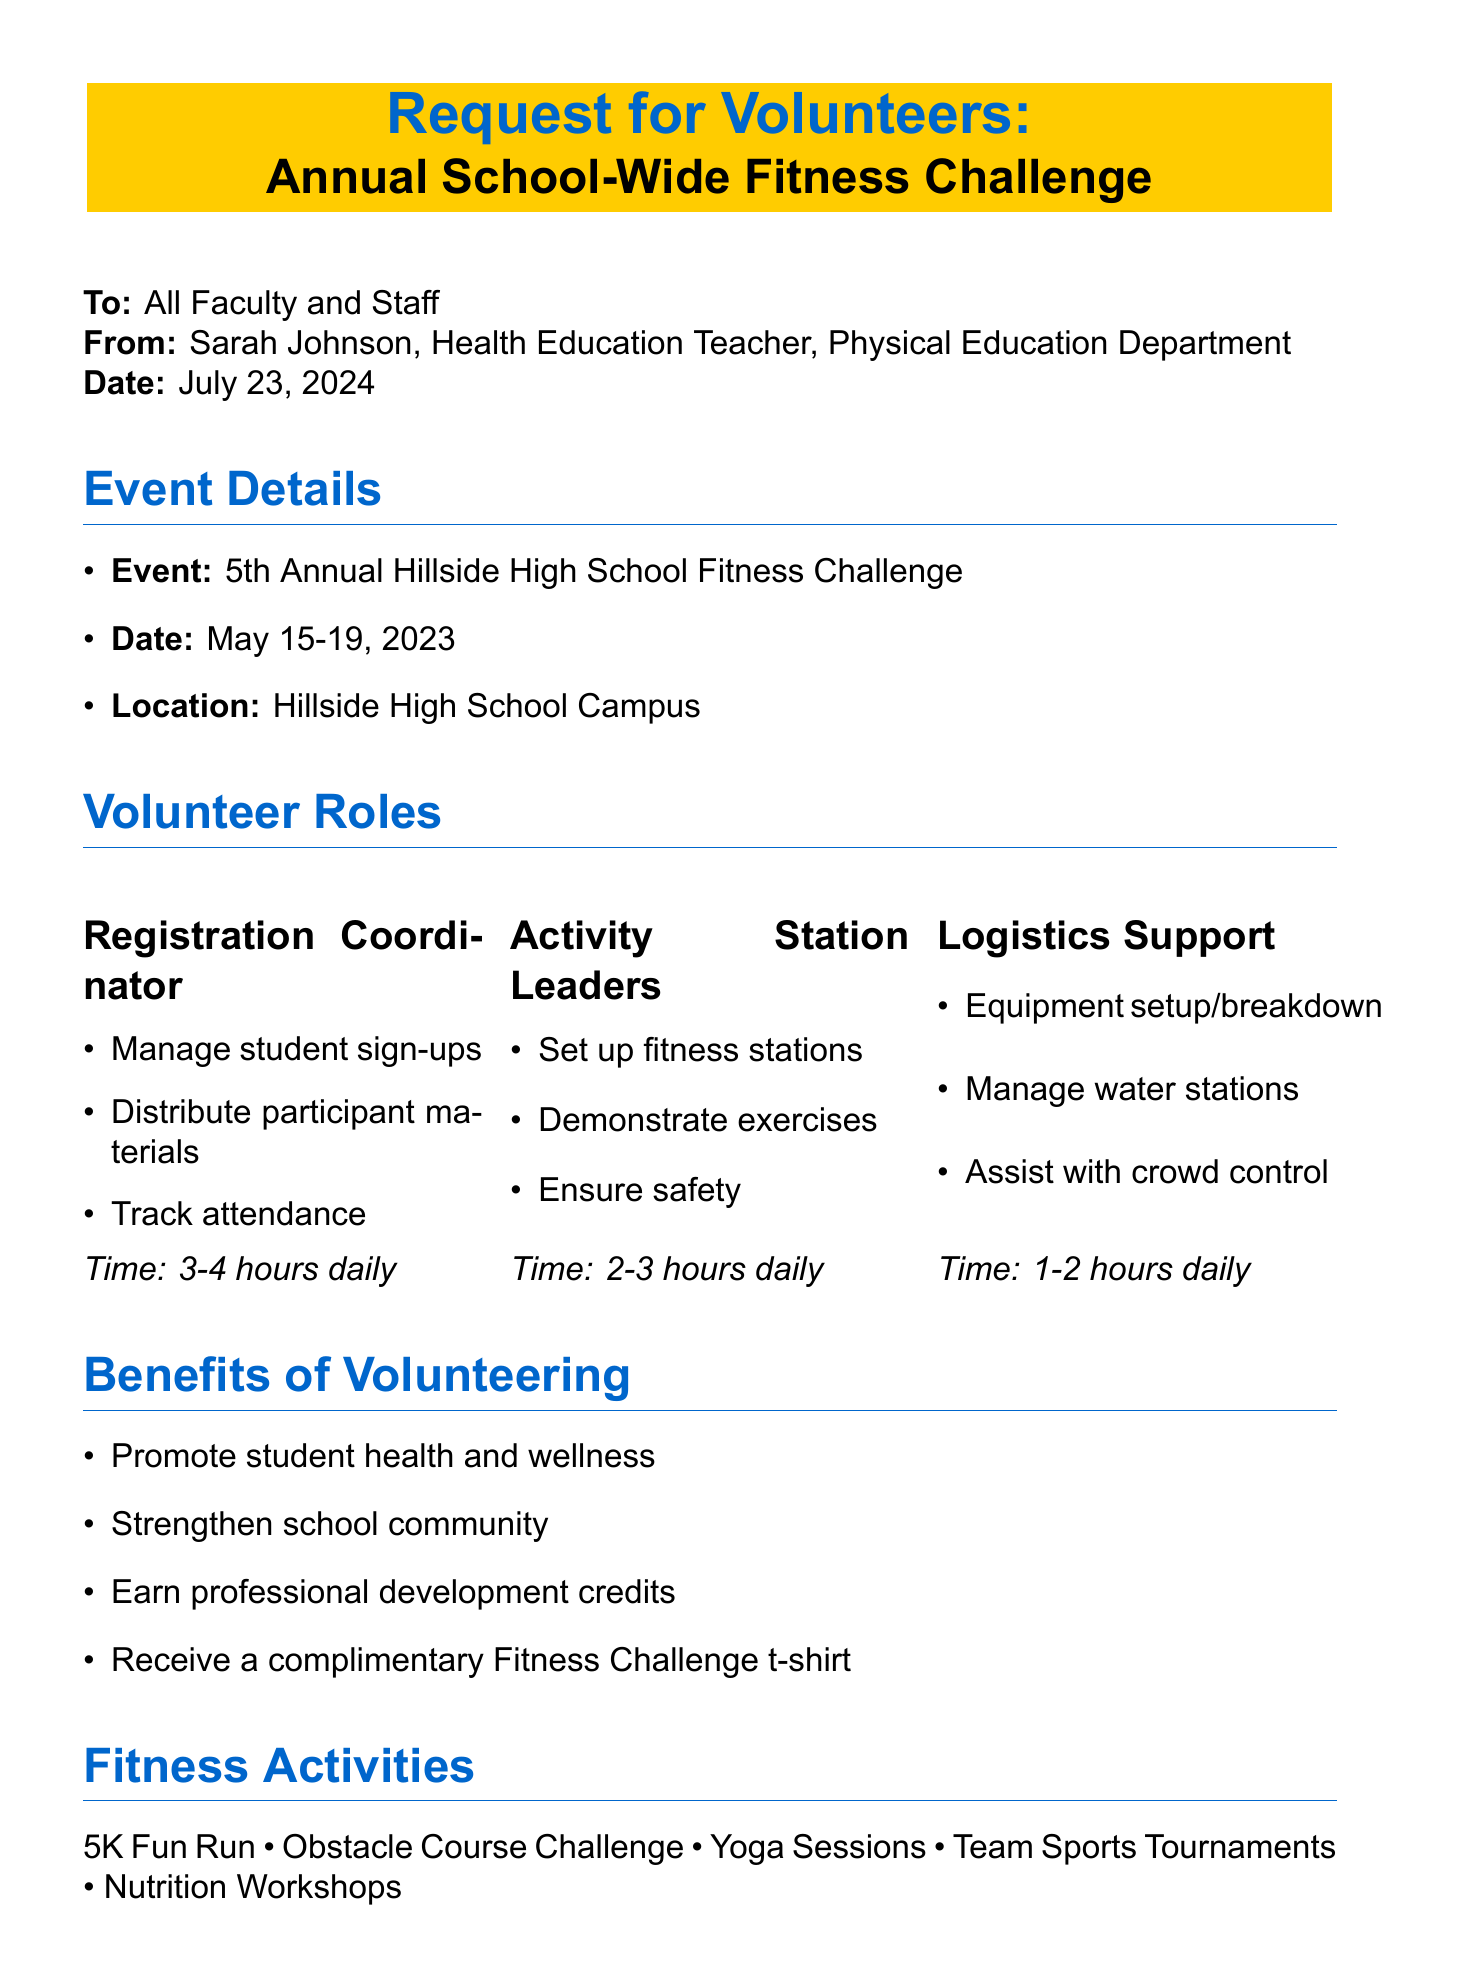what is the title of the memo? The title is prominently displayed at the top of the document as the main subject.
Answer: Request for Volunteers: Annual School-Wide Fitness Challenge who is the sender of the memo? The sender's information, including name and position, is stated clearly.
Answer: Sarah Johnson what are the dates of the fitness challenge? The document specifies the event days, which are mentioned under event details.
Answer: May 15-19, 2023 how many volunteer roles are listed in the memo? The number of roles can be counted in the Volunteer Roles section of the document.
Answer: Three what is the time commitment for the Registration Coordinator role? The time commitment for this role is explicitly mentioned in the responsibilities.
Answer: 3-4 hours daily during the event week what is one of the benefits of volunteering? The benefits are listed in a dedicated section, highlighting advantages for participants.
Answer: Promote student health and wellness when is the volunteer sign-up deadline? The document provides a specific deadline for signing up to volunteer.
Answer: April 28, 2023 what type of training will volunteers receive? The training details are included in the important notes section for clarity.
Answer: Brief training session who will provide fitness trackers? The partner organizations section mentions the provider of fitness trackers, giving credit to additional support.
Answer: Fitbit 